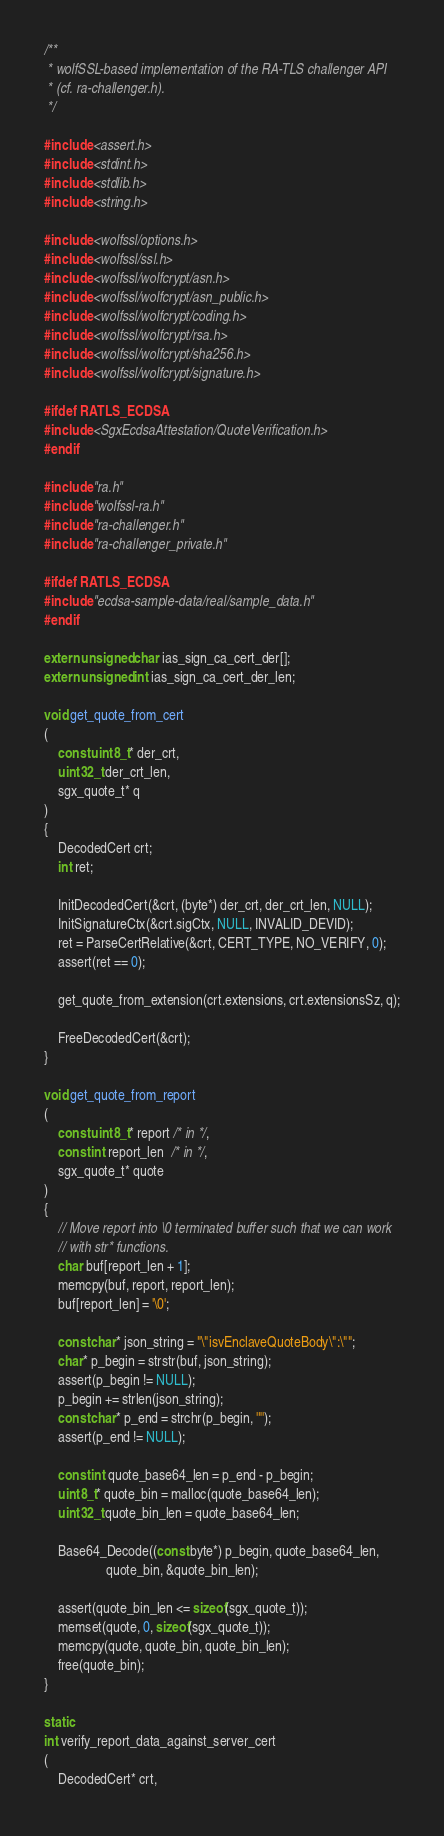<code> <loc_0><loc_0><loc_500><loc_500><_C_>/**
 * wolfSSL-based implementation of the RA-TLS challenger API
 * (cf. ra-challenger.h).
 */

#include <assert.h>
#include <stdint.h>
#include <stdlib.h>
#include <string.h>

#include <wolfssl/options.h>
#include <wolfssl/ssl.h>
#include <wolfssl/wolfcrypt/asn.h>
#include <wolfssl/wolfcrypt/asn_public.h>
#include <wolfssl/wolfcrypt/coding.h>
#include <wolfssl/wolfcrypt/rsa.h>
#include <wolfssl/wolfcrypt/sha256.h>
#include <wolfssl/wolfcrypt/signature.h>

#ifdef RATLS_ECDSA
#include <SgxEcdsaAttestation/QuoteVerification.h>
#endif

#include "ra.h"
#include "wolfssl-ra.h"
#include "ra-challenger.h"
#include "ra-challenger_private.h"

#ifdef RATLS_ECDSA
#include "ecdsa-sample-data/real/sample_data.h"
#endif

extern unsigned char ias_sign_ca_cert_der[];
extern unsigned int ias_sign_ca_cert_der_len;

void get_quote_from_cert
(
    const uint8_t* der_crt,
    uint32_t der_crt_len,
    sgx_quote_t* q
)
{
    DecodedCert crt;
    int ret;

    InitDecodedCert(&crt, (byte*) der_crt, der_crt_len, NULL);
    InitSignatureCtx(&crt.sigCtx, NULL, INVALID_DEVID);
    ret = ParseCertRelative(&crt, CERT_TYPE, NO_VERIFY, 0);
    assert(ret == 0);
    
    get_quote_from_extension(crt.extensions, crt.extensionsSz, q);

    FreeDecodedCert(&crt);
}

void get_quote_from_report
(
    const uint8_t* report /* in */,
    const int report_len  /* in */,
    sgx_quote_t* quote
)
{
    // Move report into \0 terminated buffer such that we can work
    // with str* functions.
    char buf[report_len + 1];
    memcpy(buf, report, report_len);
    buf[report_len] = '\0';

    const char* json_string = "\"isvEnclaveQuoteBody\":\"";
    char* p_begin = strstr(buf, json_string);
    assert(p_begin != NULL);
    p_begin += strlen(json_string);
    const char* p_end = strchr(p_begin, '"');
    assert(p_end != NULL);

    const int quote_base64_len = p_end - p_begin;
    uint8_t* quote_bin = malloc(quote_base64_len);
    uint32_t quote_bin_len = quote_base64_len;

    Base64_Decode((const byte*) p_begin, quote_base64_len,
                  quote_bin, &quote_bin_len);
    
    assert(quote_bin_len <= sizeof(sgx_quote_t));
    memset(quote, 0, sizeof(sgx_quote_t));
    memcpy(quote, quote_bin, quote_bin_len);
    free(quote_bin);
}

static
int verify_report_data_against_server_cert
(
    DecodedCert* crt,</code> 